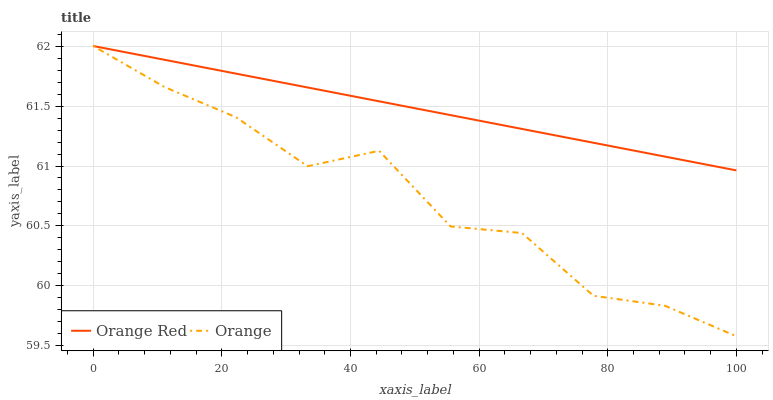Does Orange have the minimum area under the curve?
Answer yes or no. Yes. Does Orange Red have the maximum area under the curve?
Answer yes or no. Yes. Does Orange Red have the minimum area under the curve?
Answer yes or no. No. Is Orange Red the smoothest?
Answer yes or no. Yes. Is Orange the roughest?
Answer yes or no. Yes. Is Orange Red the roughest?
Answer yes or no. No. Does Orange have the lowest value?
Answer yes or no. Yes. Does Orange Red have the lowest value?
Answer yes or no. No. Does Orange Red have the highest value?
Answer yes or no. Yes. Does Orange intersect Orange Red?
Answer yes or no. Yes. Is Orange less than Orange Red?
Answer yes or no. No. Is Orange greater than Orange Red?
Answer yes or no. No. 